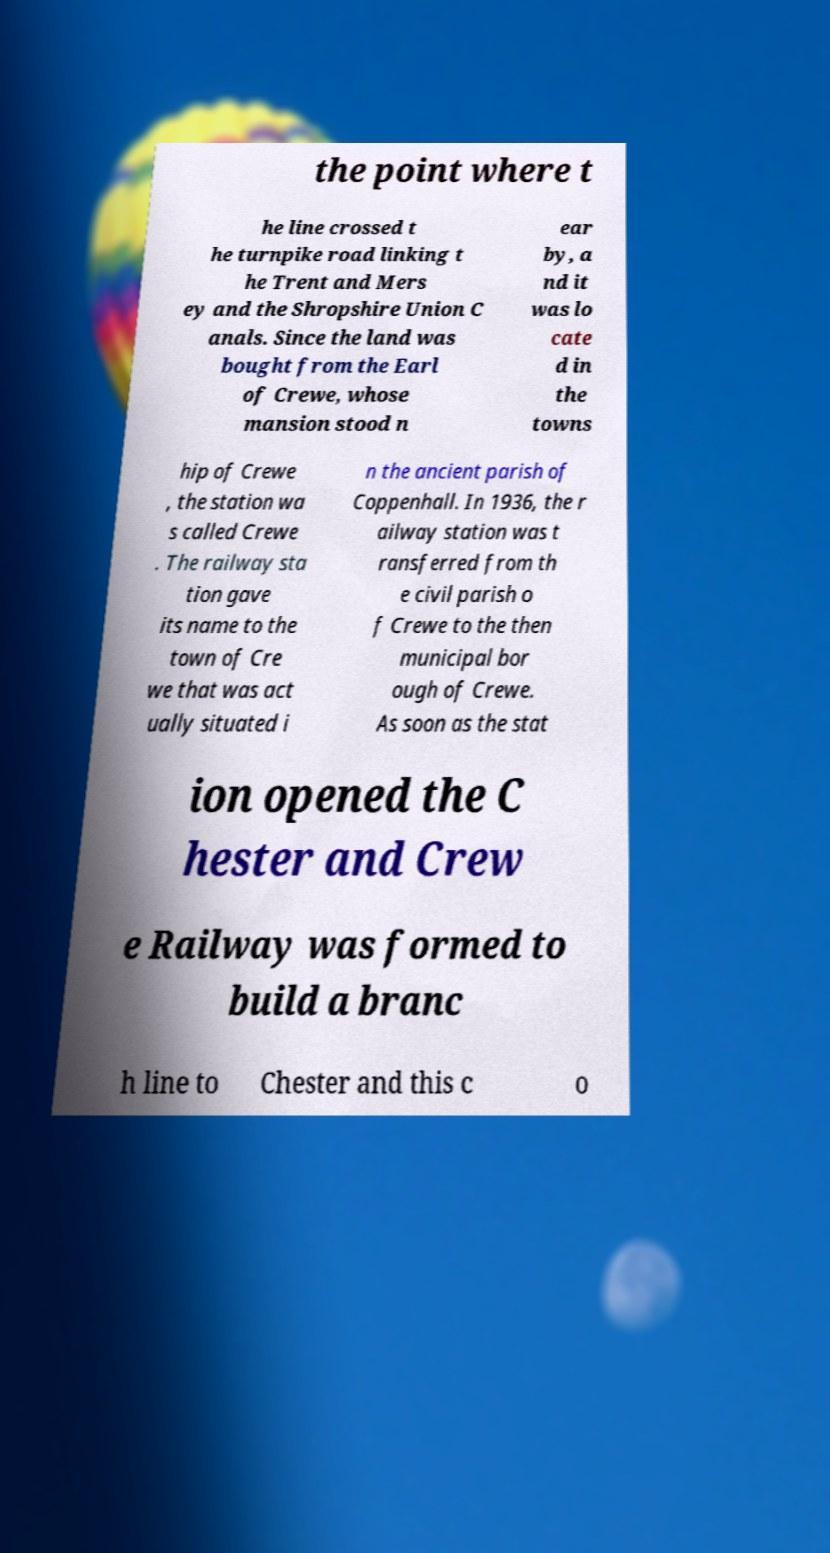I need the written content from this picture converted into text. Can you do that? the point where t he line crossed t he turnpike road linking t he Trent and Mers ey and the Shropshire Union C anals. Since the land was bought from the Earl of Crewe, whose mansion stood n ear by, a nd it was lo cate d in the towns hip of Crewe , the station wa s called Crewe . The railway sta tion gave its name to the town of Cre we that was act ually situated i n the ancient parish of Coppenhall. In 1936, the r ailway station was t ransferred from th e civil parish o f Crewe to the then municipal bor ough of Crewe. As soon as the stat ion opened the C hester and Crew e Railway was formed to build a branc h line to Chester and this c o 